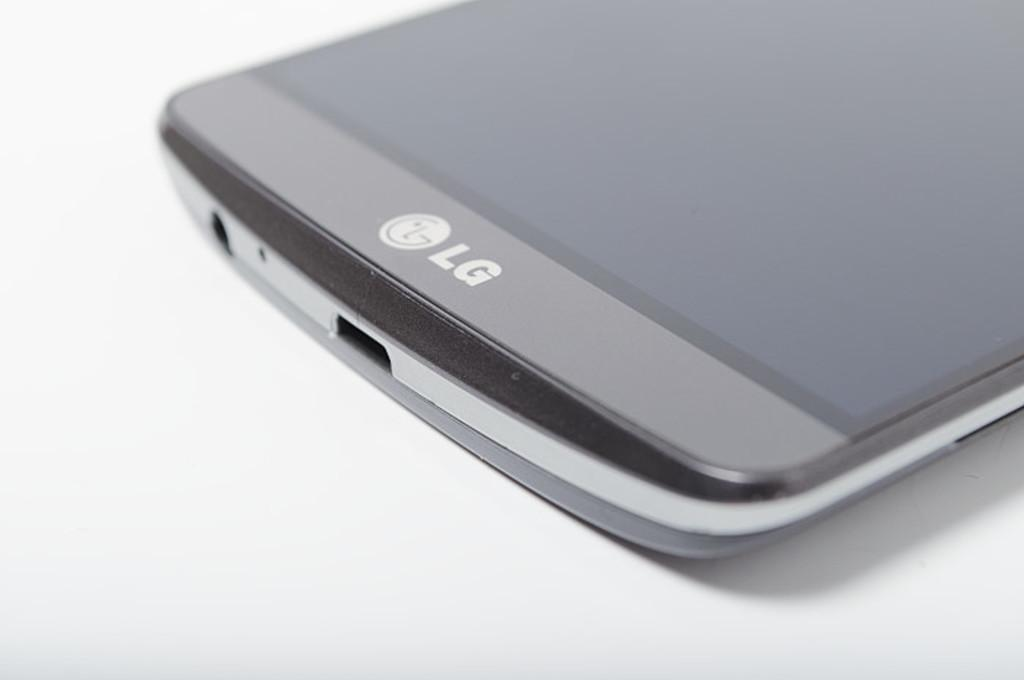<image>
Create a compact narrative representing the image presented. an LG phone that is sitting on display that is white 